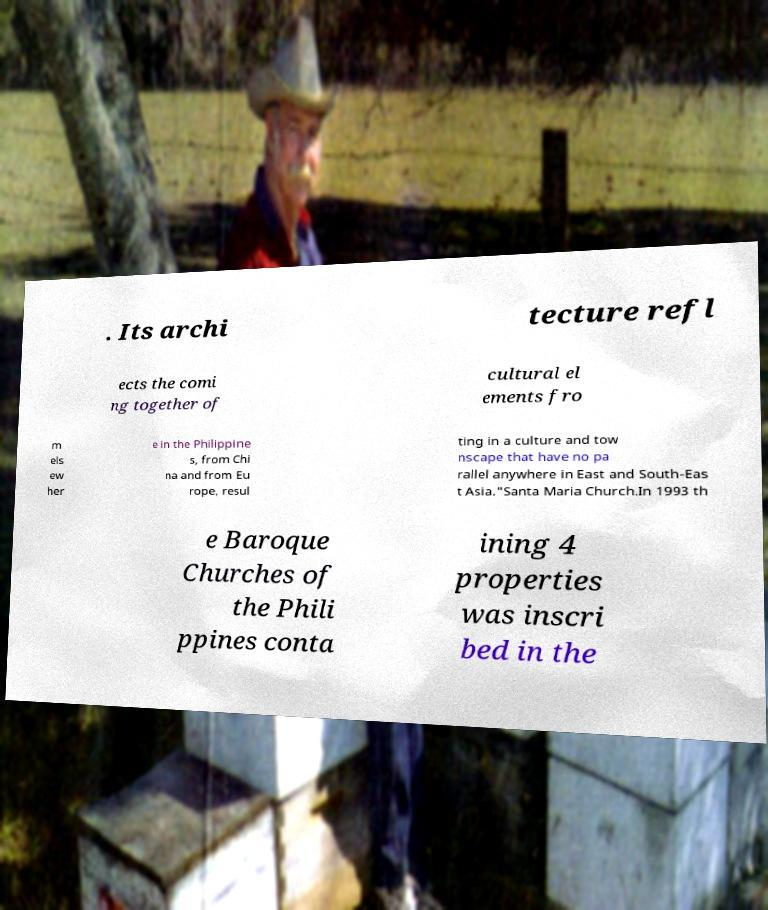What messages or text are displayed in this image? I need them in a readable, typed format. . Its archi tecture refl ects the comi ng together of cultural el ements fro m els ew her e in the Philippine s, from Chi na and from Eu rope, resul ting in a culture and tow nscape that have no pa rallel anywhere in East and South-Eas t Asia."Santa Maria Church.In 1993 th e Baroque Churches of the Phili ppines conta ining 4 properties was inscri bed in the 